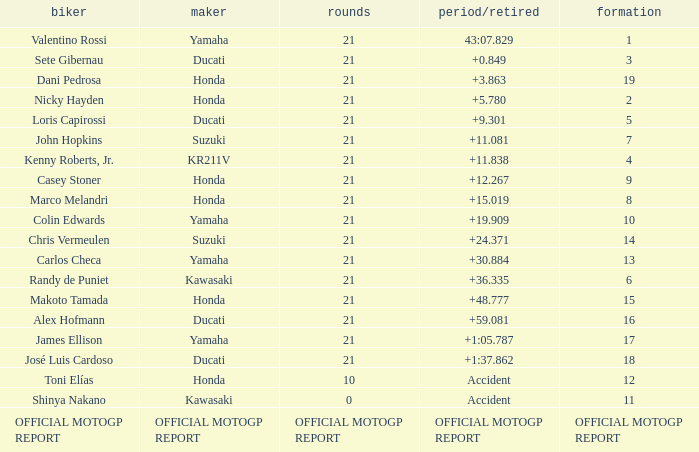What was the amount of laps for the vehicle manufactured by honda with a grid of 9? 21.0. 